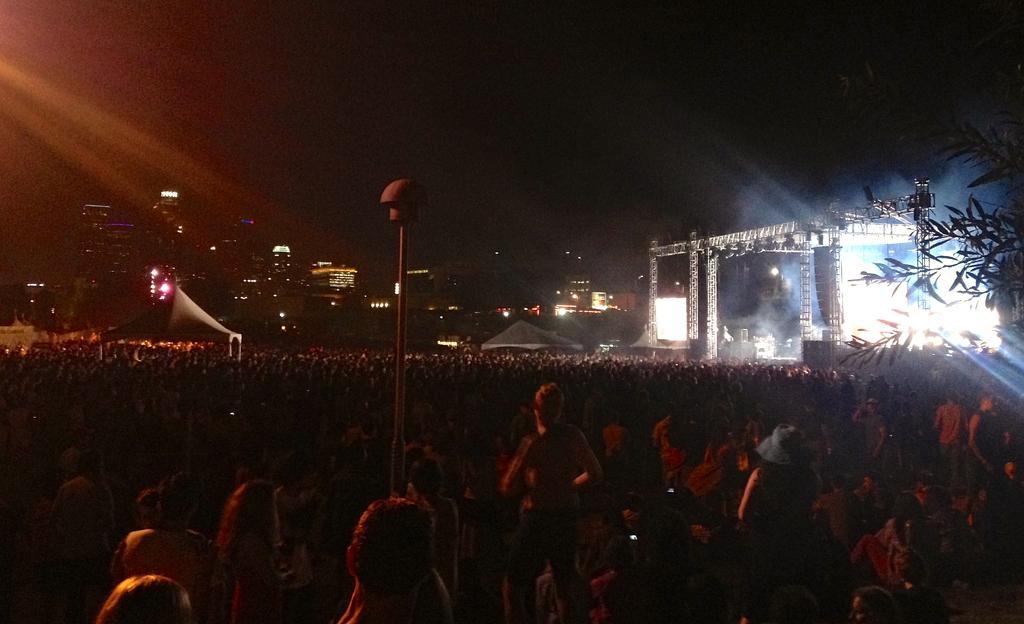Could you give a brief overview of what you see in this image? In the center of the image we can see a pole, buildings, lights, tree, tent, stage are there. At the bottom of the image group of people are there. At the top of the image sky is there. 